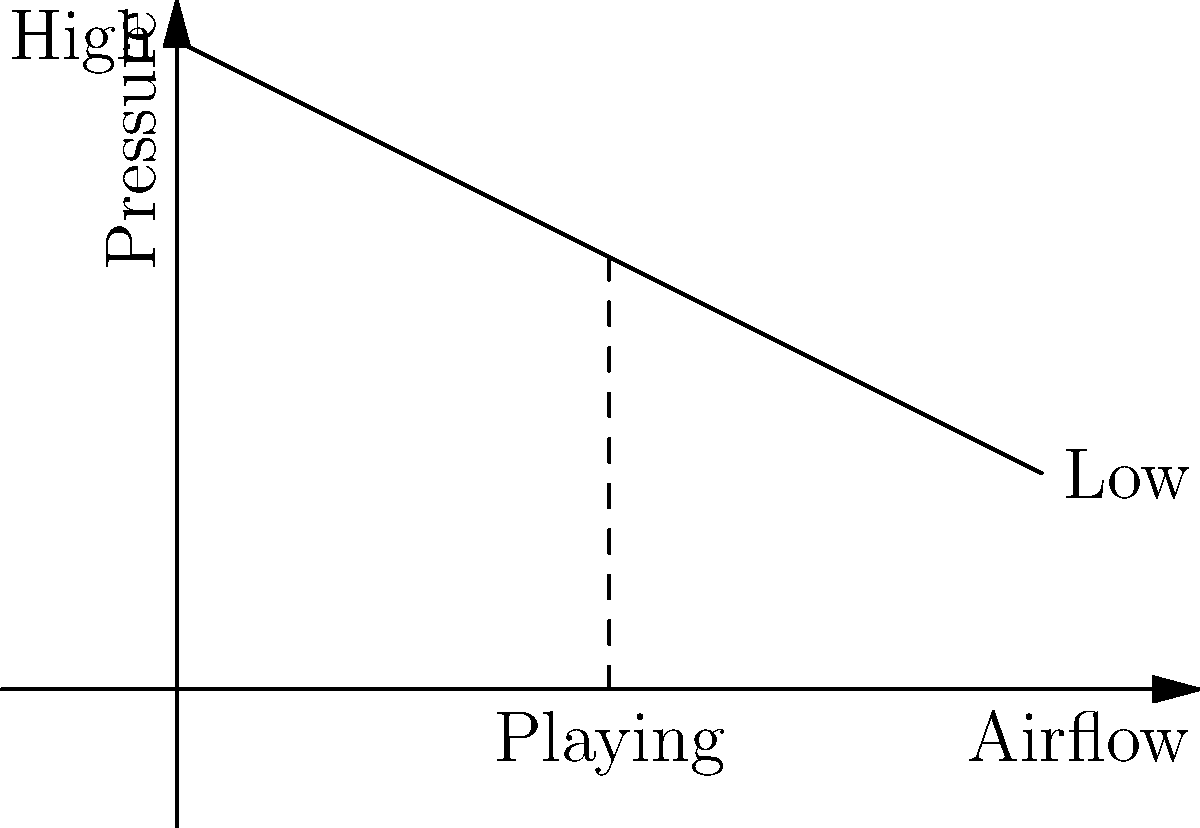As a bluegrass harmonica player, you've noticed that the sound changes when you breathe in versus out. Which statement best describes the relationship between airflow and pressure inside the harmonica during play? Let's break this down step-by-step:

1. The harmonica works on the principle of fluid dynamics, specifically the Bernoulli principle.

2. The Bernoulli principle states that an increase in the speed of a fluid occurs simultaneously with a decrease in pressure or a decrease in the fluid's potential energy.

3. When you blow into or draw air through a harmonica:
   a. You create airflow through the instrument.
   b. This airflow causes a pressure change inside the harmonica.

4. The relationship between airflow and pressure is inverse:
   - As airflow increases, pressure decreases.
   - As airflow decreases, pressure increases.

5. This relationship can be expressed mathematically as:

   $$ P + \frac{1}{2}\rho v^2 = \text{constant} $$

   Where $P$ is pressure, $\rho$ is air density, and $v$ is velocity (airflow).

6. In the context of playing a harmonica:
   - When you start to blow or draw air, the airflow increases and the pressure inside decreases.
   - This pressure difference causes the reed to vibrate, producing sound.

7. The graph shows this inverse relationship: as we move along the x-axis (increasing airflow), the pressure (y-axis) decreases.

Therefore, the correct statement is that as airflow increases during play, the pressure inside the harmonica decreases.
Answer: Inverse relationship: as airflow increases, pressure decreases. 